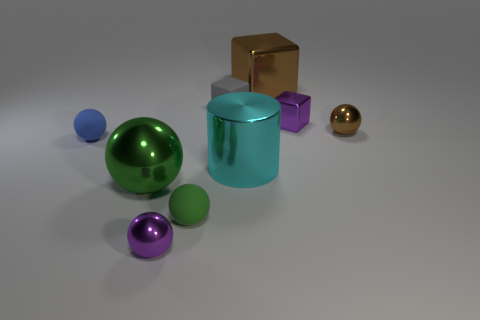Subtract all brown spheres. How many spheres are left? 4 Add 1 tiny brown spheres. How many objects exist? 10 Subtract all cyan cubes. Subtract all cyan cylinders. How many cubes are left? 3 Subtract all cylinders. How many objects are left? 8 Add 3 big cubes. How many big cubes are left? 4 Add 4 yellow matte cubes. How many yellow matte cubes exist? 4 Subtract 1 gray cubes. How many objects are left? 8 Subtract all brown metal spheres. Subtract all cyan metal things. How many objects are left? 7 